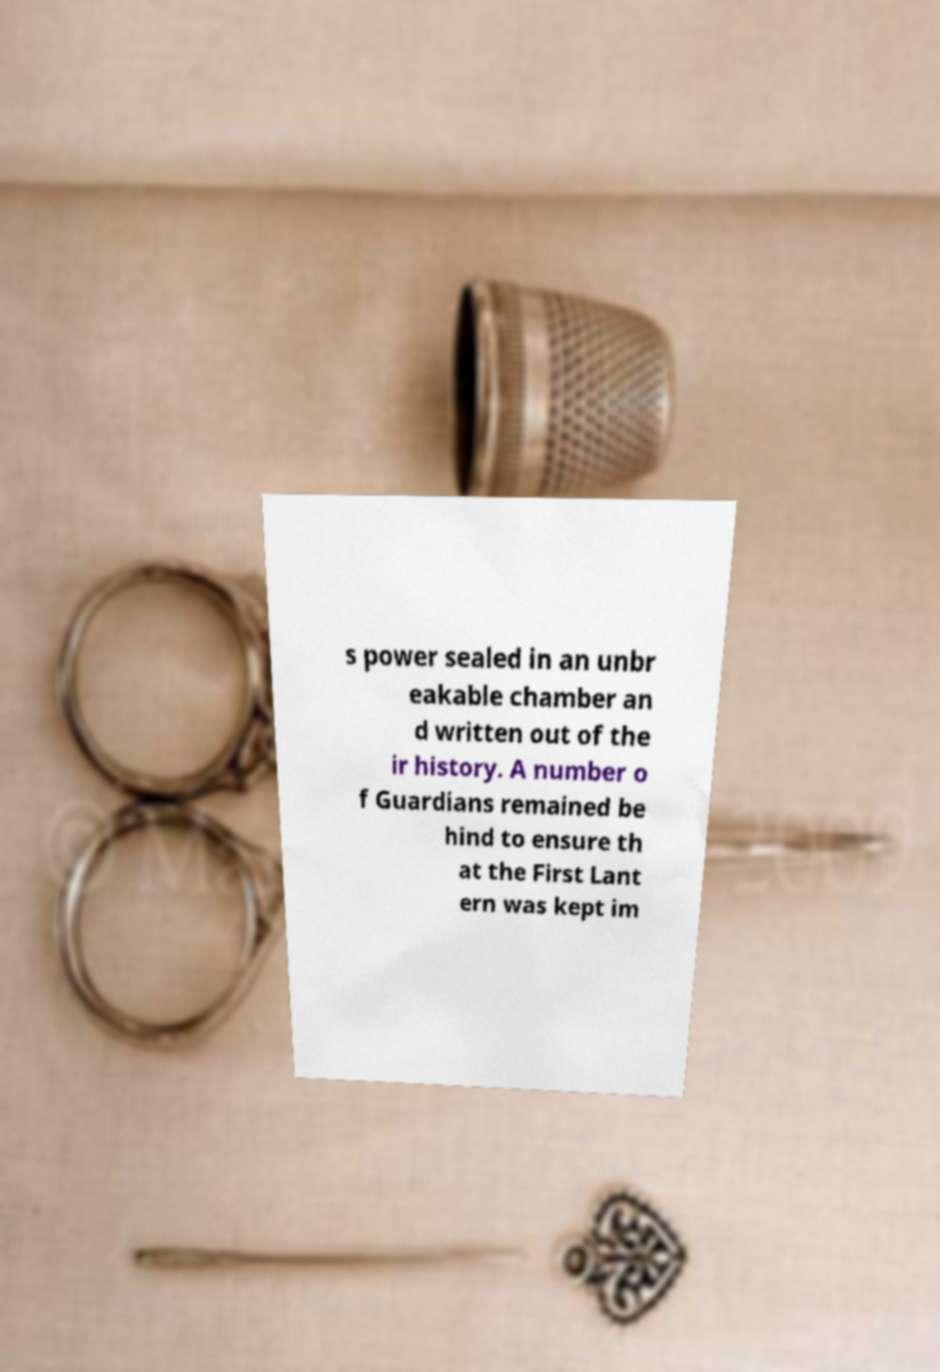Please identify and transcribe the text found in this image. s power sealed in an unbr eakable chamber an d written out of the ir history. A number o f Guardians remained be hind to ensure th at the First Lant ern was kept im 